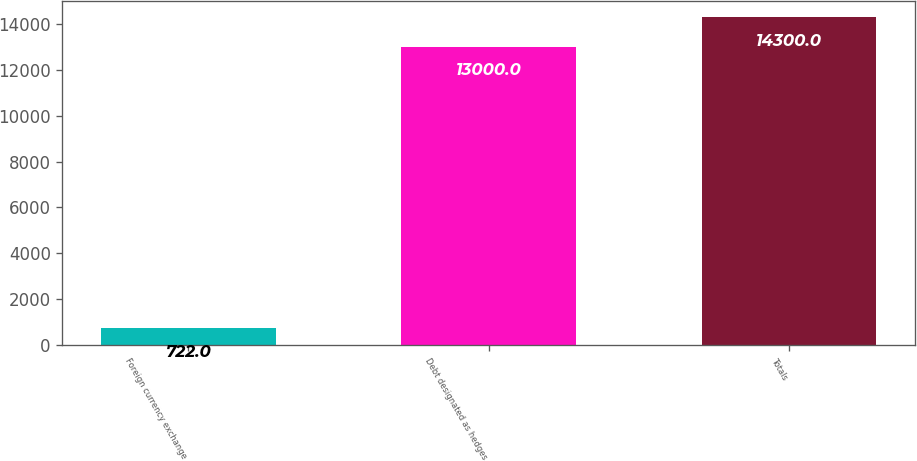Convert chart to OTSL. <chart><loc_0><loc_0><loc_500><loc_500><bar_chart><fcel>Foreign currency exchange<fcel>Debt designated as hedges<fcel>Totals<nl><fcel>722<fcel>13000<fcel>14300<nl></chart> 